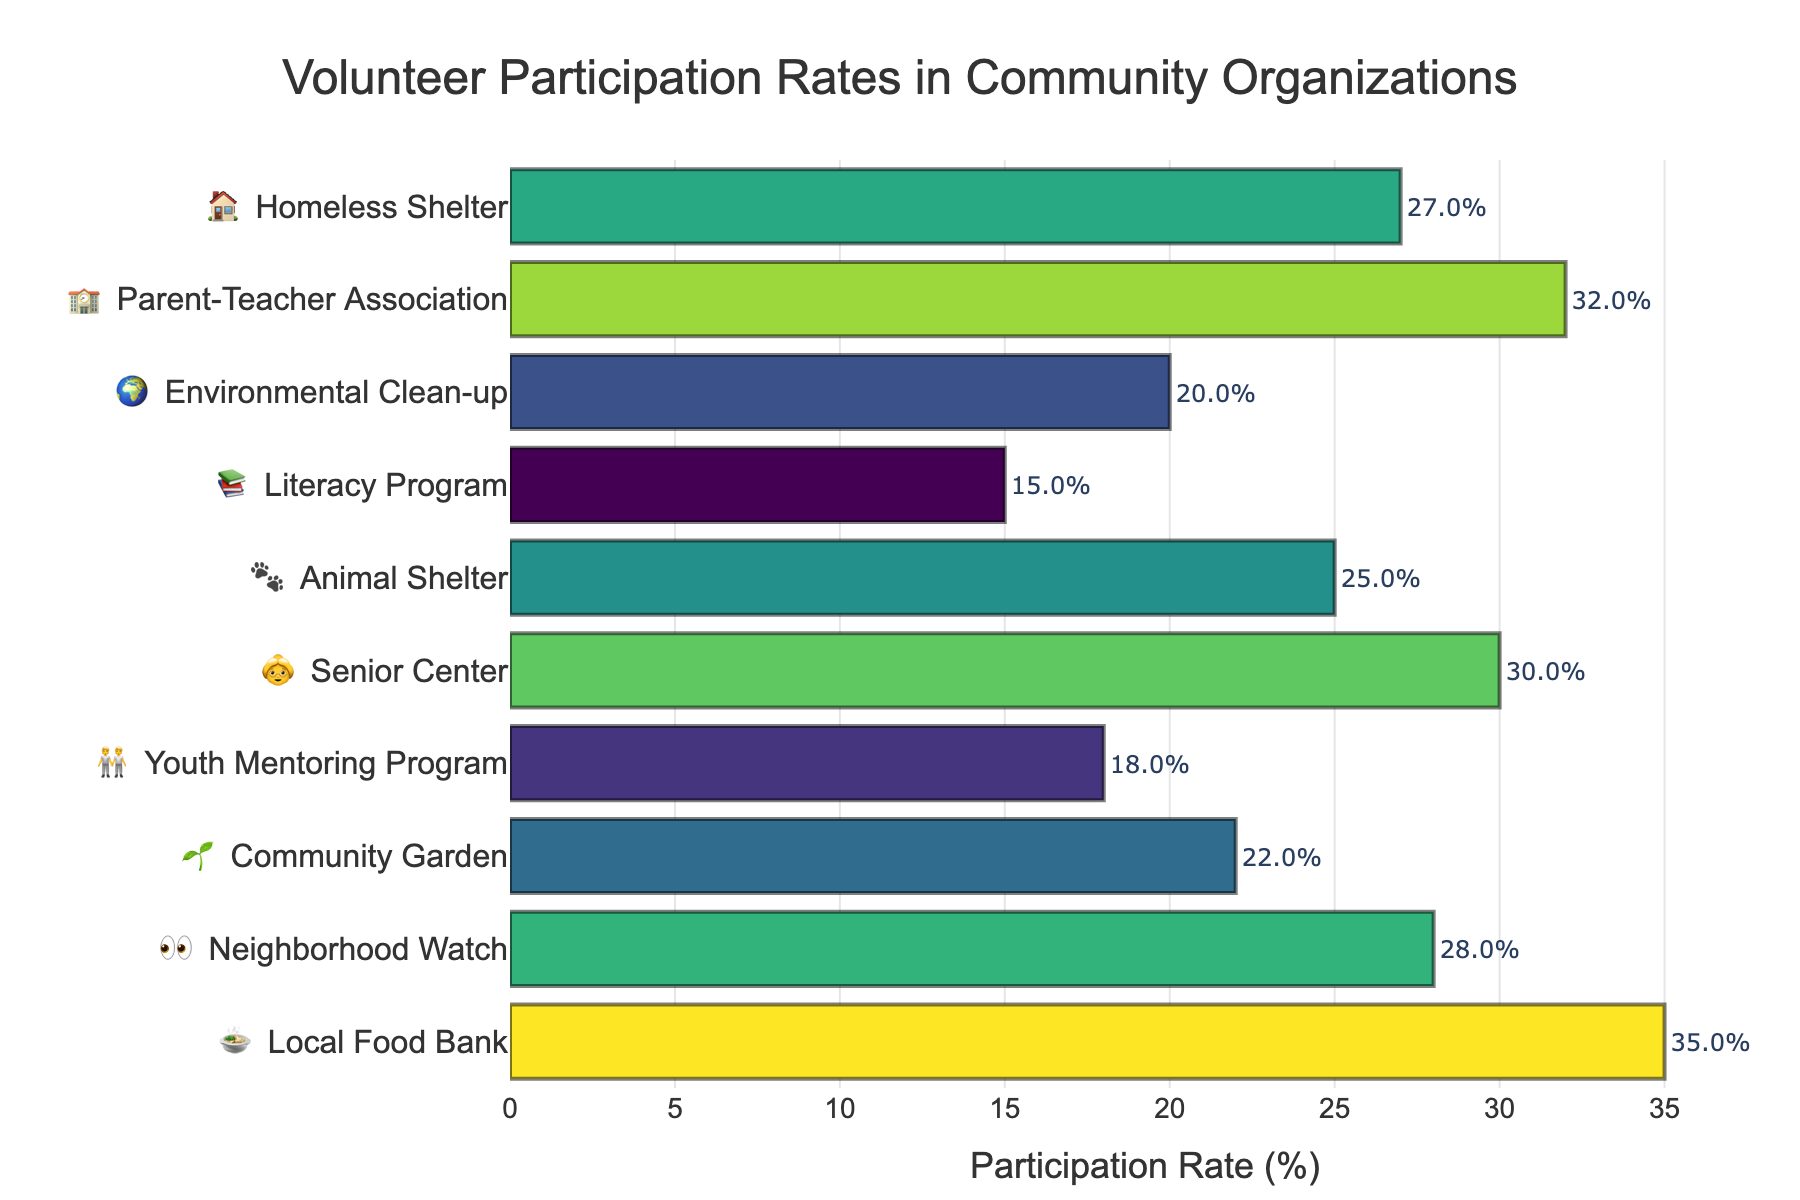What's the title of the chart? The title is found at the top center of the chart, usually in larger and bolder text than other elements.
Answer: Volunteer Participation Rates in Community Organizations Which organization has the highest participation rate? Look for the bar that extends the farthest to the right; the text for that bar will indicate the organization.
Answer: Local Food Bank What is the participation rate for the Youth Mentoring Program? Find the bar labeled with the emoji 🧑‍🤝‍🧑 and "Youth Mentoring Program" to its right. The text at the end of the bar will show the percentage.
Answer: 18% Compare the participation rates of the Senior Center and the Neighborhood Watch. Which is higher? Identify the bars for 👵 Senior Center and 👀 Neighborhood Watch, then compare their lengths or the percentage text at the ends of the bars.
Answer: Senior Center What is the average participation rate across all organizations? Add all participation rates: (35 + 28 + 22 + 18 + 30 + 25 + 15 + 20 + 32 + 27) = 252. Divide by the number of organizations: 252 / 10.
Answer: 25.2% How many organizations have a participation rate above 25%? Identify and count the bars where the participation rate text at the ends is greater than 25.
Answer: 5 What's the difference in participation rates between the highest and lowest organizations? Identify the highest participation rate (Local Food Bank, 35%) and the lowest (Literacy Program, 15%), then subtract the latter from the former: 35 - 15.
Answer: 20% Which organizations have a participation rate less than the overall average? First, find the average (25.2%). Then, identify the bars with rates less than this value.
Answer: Youth Mentoring Program, Literacy Program, Environmental Clean-up How does the participation rate for the Parent-Teacher Association compare with the Environmental Clean-up? Look for the bars labeled 🏫 Parent-Teacher Association and 🌍 Environmental Clean-up. Note their percentages and compare: 32% (Parent-Teacher Association) versus 20% (Environmental Clean-up).
Answer: Higher List the organizations in descending order of participation rate. Starting from the organization with the longest bar to the shortest: Local Food Bank (35%), Parent-Teacher Association (32%), Senior Center (30%), Neighborhood Watch (28%), Homeless Shelter (27%), Animal Shelter (25%), Community Garden (22%), Environmental Clean-up (20%), Youth Mentoring Program (18%), Literacy Program (15%).
Answer: Local Food Bank, Parent-Teacher Association, Senior Center, Neighborhood Watch, Homeless Shelter, Animal Shelter, Community Garden, Environmental Clean-up, Youth Mentoring Program, Literacy Program 